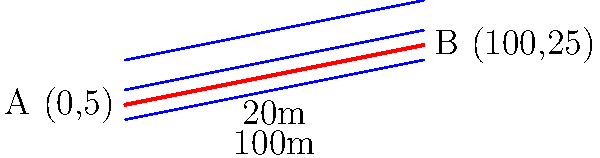As a tech support specialist familiar with optimizing server configurations, consider a drainage system installation project. Given the terrain contours shown in the diagram, calculate the optimal slope for the drainage system between points A and B. Express your answer as a percentage. To determine the optimal slope for the drainage system, we need to follow these steps:

1. Identify the elevation change:
   - Point A elevation: 5 m
   - Point B elevation: 25 m
   - Elevation change = 25 m - 5 m = 20 m

2. Identify the horizontal distance:
   - The diagram shows the horizontal distance as 100 m

3. Calculate the slope using the formula:
   $$ \text{Slope} = \frac{\text{Elevation Change}}{\text{Horizontal Distance}} \times 100\% $$

4. Plug in the values:
   $$ \text{Slope} = \frac{20 \text{ m}}{100 \text{ m}} \times 100\% = 0.2 \times 100\% = 20\% $$

The optimal slope for the drainage system, based on the terrain contours, is 20%.

This approach to problem-solving is similar to optimizing server configurations, where you need to analyze system parameters and calculate optimal settings for best performance.
Answer: 20% 